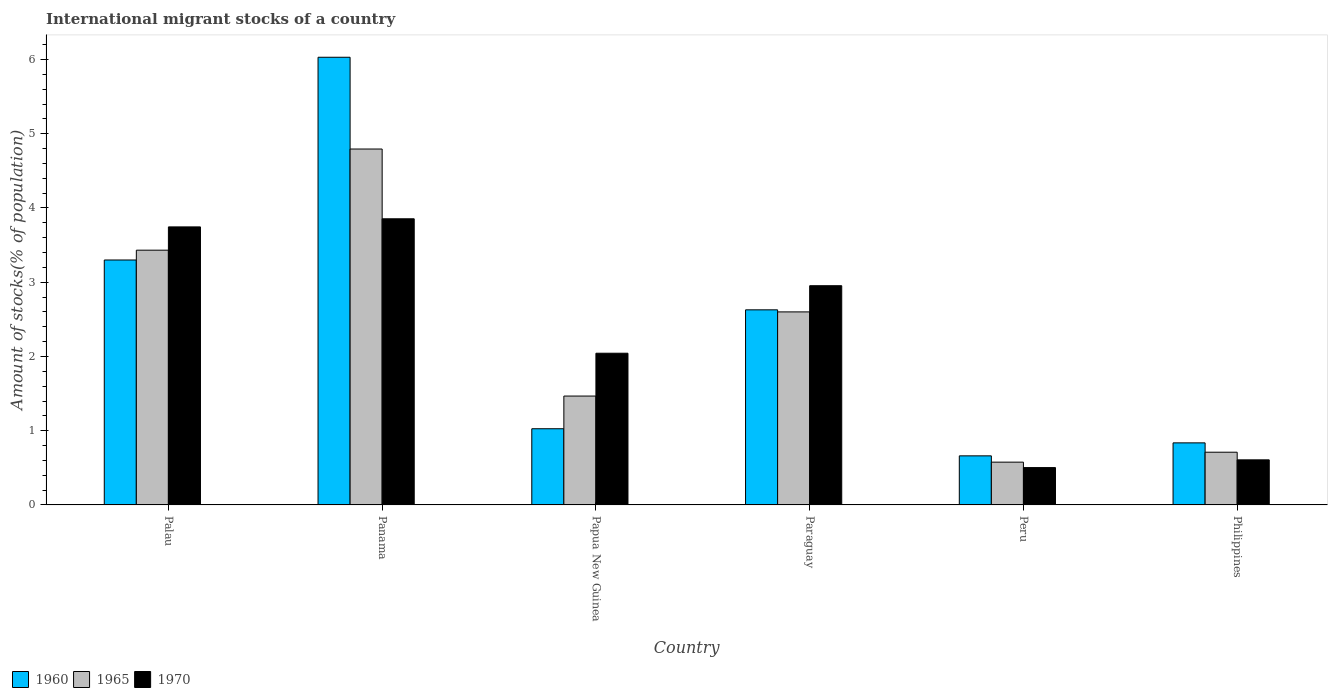Are the number of bars on each tick of the X-axis equal?
Give a very brief answer. Yes. How many bars are there on the 4th tick from the left?
Provide a short and direct response. 3. How many bars are there on the 1st tick from the right?
Your response must be concise. 3. What is the label of the 1st group of bars from the left?
Your answer should be compact. Palau. In how many cases, is the number of bars for a given country not equal to the number of legend labels?
Offer a very short reply. 0. What is the amount of stocks in in 1970 in Panama?
Provide a succinct answer. 3.85. Across all countries, what is the maximum amount of stocks in in 1960?
Keep it short and to the point. 6.03. Across all countries, what is the minimum amount of stocks in in 1960?
Provide a succinct answer. 0.66. In which country was the amount of stocks in in 1960 maximum?
Give a very brief answer. Panama. In which country was the amount of stocks in in 1970 minimum?
Keep it short and to the point. Peru. What is the total amount of stocks in in 1965 in the graph?
Your answer should be compact. 13.58. What is the difference between the amount of stocks in in 1965 in Palau and that in Philippines?
Your answer should be compact. 2.72. What is the difference between the amount of stocks in in 1960 in Philippines and the amount of stocks in in 1965 in Panama?
Offer a terse response. -3.96. What is the average amount of stocks in in 1965 per country?
Offer a very short reply. 2.26. What is the difference between the amount of stocks in of/in 1970 and amount of stocks in of/in 1965 in Peru?
Provide a succinct answer. -0.07. What is the ratio of the amount of stocks in in 1960 in Peru to that in Philippines?
Give a very brief answer. 0.79. Is the difference between the amount of stocks in in 1970 in Panama and Paraguay greater than the difference between the amount of stocks in in 1965 in Panama and Paraguay?
Your response must be concise. No. What is the difference between the highest and the second highest amount of stocks in in 1970?
Provide a succinct answer. 0.79. What is the difference between the highest and the lowest amount of stocks in in 1970?
Your answer should be compact. 3.35. In how many countries, is the amount of stocks in in 1960 greater than the average amount of stocks in in 1960 taken over all countries?
Make the answer very short. 3. Is the sum of the amount of stocks in in 1960 in Palau and Papua New Guinea greater than the maximum amount of stocks in in 1965 across all countries?
Your answer should be compact. No. What does the 3rd bar from the left in Paraguay represents?
Give a very brief answer. 1970. What does the 2nd bar from the right in Philippines represents?
Offer a terse response. 1965. Are all the bars in the graph horizontal?
Provide a short and direct response. No. How many countries are there in the graph?
Your answer should be very brief. 6. What is the difference between two consecutive major ticks on the Y-axis?
Ensure brevity in your answer.  1. What is the title of the graph?
Offer a very short reply. International migrant stocks of a country. What is the label or title of the X-axis?
Keep it short and to the point. Country. What is the label or title of the Y-axis?
Give a very brief answer. Amount of stocks(% of population). What is the Amount of stocks(% of population) of 1960 in Palau?
Provide a succinct answer. 3.3. What is the Amount of stocks(% of population) in 1965 in Palau?
Make the answer very short. 3.43. What is the Amount of stocks(% of population) of 1970 in Palau?
Give a very brief answer. 3.75. What is the Amount of stocks(% of population) of 1960 in Panama?
Your response must be concise. 6.03. What is the Amount of stocks(% of population) of 1965 in Panama?
Offer a terse response. 4.79. What is the Amount of stocks(% of population) of 1970 in Panama?
Make the answer very short. 3.85. What is the Amount of stocks(% of population) in 1960 in Papua New Guinea?
Ensure brevity in your answer.  1.03. What is the Amount of stocks(% of population) of 1965 in Papua New Guinea?
Ensure brevity in your answer.  1.47. What is the Amount of stocks(% of population) in 1970 in Papua New Guinea?
Your answer should be very brief. 2.04. What is the Amount of stocks(% of population) of 1960 in Paraguay?
Your answer should be very brief. 2.63. What is the Amount of stocks(% of population) in 1965 in Paraguay?
Your response must be concise. 2.6. What is the Amount of stocks(% of population) of 1970 in Paraguay?
Ensure brevity in your answer.  2.95. What is the Amount of stocks(% of population) of 1960 in Peru?
Offer a terse response. 0.66. What is the Amount of stocks(% of population) of 1965 in Peru?
Provide a short and direct response. 0.58. What is the Amount of stocks(% of population) of 1970 in Peru?
Your answer should be very brief. 0.5. What is the Amount of stocks(% of population) of 1960 in Philippines?
Your answer should be compact. 0.84. What is the Amount of stocks(% of population) of 1965 in Philippines?
Make the answer very short. 0.71. What is the Amount of stocks(% of population) in 1970 in Philippines?
Keep it short and to the point. 0.61. Across all countries, what is the maximum Amount of stocks(% of population) in 1960?
Offer a terse response. 6.03. Across all countries, what is the maximum Amount of stocks(% of population) in 1965?
Your answer should be very brief. 4.79. Across all countries, what is the maximum Amount of stocks(% of population) of 1970?
Make the answer very short. 3.85. Across all countries, what is the minimum Amount of stocks(% of population) of 1960?
Make the answer very short. 0.66. Across all countries, what is the minimum Amount of stocks(% of population) in 1965?
Give a very brief answer. 0.58. Across all countries, what is the minimum Amount of stocks(% of population) of 1970?
Give a very brief answer. 0.5. What is the total Amount of stocks(% of population) in 1960 in the graph?
Provide a short and direct response. 14.48. What is the total Amount of stocks(% of population) of 1965 in the graph?
Keep it short and to the point. 13.58. What is the total Amount of stocks(% of population) in 1970 in the graph?
Keep it short and to the point. 13.71. What is the difference between the Amount of stocks(% of population) of 1960 in Palau and that in Panama?
Ensure brevity in your answer.  -2.73. What is the difference between the Amount of stocks(% of population) of 1965 in Palau and that in Panama?
Your answer should be very brief. -1.36. What is the difference between the Amount of stocks(% of population) in 1970 in Palau and that in Panama?
Provide a succinct answer. -0.11. What is the difference between the Amount of stocks(% of population) in 1960 in Palau and that in Papua New Guinea?
Your answer should be very brief. 2.27. What is the difference between the Amount of stocks(% of population) in 1965 in Palau and that in Papua New Guinea?
Provide a succinct answer. 1.97. What is the difference between the Amount of stocks(% of population) in 1970 in Palau and that in Papua New Guinea?
Provide a short and direct response. 1.7. What is the difference between the Amount of stocks(% of population) of 1960 in Palau and that in Paraguay?
Offer a very short reply. 0.67. What is the difference between the Amount of stocks(% of population) in 1965 in Palau and that in Paraguay?
Keep it short and to the point. 0.83. What is the difference between the Amount of stocks(% of population) in 1970 in Palau and that in Paraguay?
Provide a short and direct response. 0.79. What is the difference between the Amount of stocks(% of population) in 1960 in Palau and that in Peru?
Offer a very short reply. 2.64. What is the difference between the Amount of stocks(% of population) of 1965 in Palau and that in Peru?
Your answer should be compact. 2.86. What is the difference between the Amount of stocks(% of population) of 1970 in Palau and that in Peru?
Your answer should be compact. 3.24. What is the difference between the Amount of stocks(% of population) of 1960 in Palau and that in Philippines?
Your answer should be very brief. 2.46. What is the difference between the Amount of stocks(% of population) of 1965 in Palau and that in Philippines?
Provide a short and direct response. 2.72. What is the difference between the Amount of stocks(% of population) of 1970 in Palau and that in Philippines?
Ensure brevity in your answer.  3.14. What is the difference between the Amount of stocks(% of population) of 1960 in Panama and that in Papua New Guinea?
Offer a terse response. 5. What is the difference between the Amount of stocks(% of population) in 1965 in Panama and that in Papua New Guinea?
Offer a terse response. 3.33. What is the difference between the Amount of stocks(% of population) in 1970 in Panama and that in Papua New Guinea?
Provide a succinct answer. 1.81. What is the difference between the Amount of stocks(% of population) of 1960 in Panama and that in Paraguay?
Provide a succinct answer. 3.4. What is the difference between the Amount of stocks(% of population) of 1965 in Panama and that in Paraguay?
Your answer should be very brief. 2.19. What is the difference between the Amount of stocks(% of population) in 1970 in Panama and that in Paraguay?
Offer a terse response. 0.9. What is the difference between the Amount of stocks(% of population) in 1960 in Panama and that in Peru?
Provide a succinct answer. 5.37. What is the difference between the Amount of stocks(% of population) of 1965 in Panama and that in Peru?
Keep it short and to the point. 4.22. What is the difference between the Amount of stocks(% of population) of 1970 in Panama and that in Peru?
Keep it short and to the point. 3.35. What is the difference between the Amount of stocks(% of population) of 1960 in Panama and that in Philippines?
Give a very brief answer. 5.19. What is the difference between the Amount of stocks(% of population) of 1965 in Panama and that in Philippines?
Offer a terse response. 4.08. What is the difference between the Amount of stocks(% of population) of 1970 in Panama and that in Philippines?
Offer a very short reply. 3.25. What is the difference between the Amount of stocks(% of population) in 1960 in Papua New Guinea and that in Paraguay?
Make the answer very short. -1.6. What is the difference between the Amount of stocks(% of population) in 1965 in Papua New Guinea and that in Paraguay?
Keep it short and to the point. -1.13. What is the difference between the Amount of stocks(% of population) in 1970 in Papua New Guinea and that in Paraguay?
Your answer should be compact. -0.91. What is the difference between the Amount of stocks(% of population) in 1960 in Papua New Guinea and that in Peru?
Provide a succinct answer. 0.37. What is the difference between the Amount of stocks(% of population) in 1965 in Papua New Guinea and that in Peru?
Your response must be concise. 0.89. What is the difference between the Amount of stocks(% of population) of 1970 in Papua New Guinea and that in Peru?
Offer a very short reply. 1.54. What is the difference between the Amount of stocks(% of population) in 1960 in Papua New Guinea and that in Philippines?
Make the answer very short. 0.19. What is the difference between the Amount of stocks(% of population) in 1965 in Papua New Guinea and that in Philippines?
Ensure brevity in your answer.  0.76. What is the difference between the Amount of stocks(% of population) in 1970 in Papua New Guinea and that in Philippines?
Provide a succinct answer. 1.44. What is the difference between the Amount of stocks(% of population) in 1960 in Paraguay and that in Peru?
Make the answer very short. 1.97. What is the difference between the Amount of stocks(% of population) in 1965 in Paraguay and that in Peru?
Offer a terse response. 2.02. What is the difference between the Amount of stocks(% of population) of 1970 in Paraguay and that in Peru?
Offer a very short reply. 2.45. What is the difference between the Amount of stocks(% of population) of 1960 in Paraguay and that in Philippines?
Provide a short and direct response. 1.79. What is the difference between the Amount of stocks(% of population) of 1965 in Paraguay and that in Philippines?
Your answer should be very brief. 1.89. What is the difference between the Amount of stocks(% of population) in 1970 in Paraguay and that in Philippines?
Keep it short and to the point. 2.35. What is the difference between the Amount of stocks(% of population) of 1960 in Peru and that in Philippines?
Offer a terse response. -0.17. What is the difference between the Amount of stocks(% of population) in 1965 in Peru and that in Philippines?
Offer a terse response. -0.13. What is the difference between the Amount of stocks(% of population) in 1970 in Peru and that in Philippines?
Your answer should be compact. -0.1. What is the difference between the Amount of stocks(% of population) in 1960 in Palau and the Amount of stocks(% of population) in 1965 in Panama?
Your response must be concise. -1.49. What is the difference between the Amount of stocks(% of population) of 1960 in Palau and the Amount of stocks(% of population) of 1970 in Panama?
Keep it short and to the point. -0.56. What is the difference between the Amount of stocks(% of population) of 1965 in Palau and the Amount of stocks(% of population) of 1970 in Panama?
Ensure brevity in your answer.  -0.42. What is the difference between the Amount of stocks(% of population) in 1960 in Palau and the Amount of stocks(% of population) in 1965 in Papua New Guinea?
Make the answer very short. 1.83. What is the difference between the Amount of stocks(% of population) in 1960 in Palau and the Amount of stocks(% of population) in 1970 in Papua New Guinea?
Give a very brief answer. 1.26. What is the difference between the Amount of stocks(% of population) in 1965 in Palau and the Amount of stocks(% of population) in 1970 in Papua New Guinea?
Ensure brevity in your answer.  1.39. What is the difference between the Amount of stocks(% of population) of 1960 in Palau and the Amount of stocks(% of population) of 1965 in Paraguay?
Provide a succinct answer. 0.7. What is the difference between the Amount of stocks(% of population) of 1960 in Palau and the Amount of stocks(% of population) of 1970 in Paraguay?
Give a very brief answer. 0.35. What is the difference between the Amount of stocks(% of population) in 1965 in Palau and the Amount of stocks(% of population) in 1970 in Paraguay?
Provide a succinct answer. 0.48. What is the difference between the Amount of stocks(% of population) in 1960 in Palau and the Amount of stocks(% of population) in 1965 in Peru?
Keep it short and to the point. 2.72. What is the difference between the Amount of stocks(% of population) of 1960 in Palau and the Amount of stocks(% of population) of 1970 in Peru?
Give a very brief answer. 2.8. What is the difference between the Amount of stocks(% of population) in 1965 in Palau and the Amount of stocks(% of population) in 1970 in Peru?
Offer a terse response. 2.93. What is the difference between the Amount of stocks(% of population) in 1960 in Palau and the Amount of stocks(% of population) in 1965 in Philippines?
Provide a succinct answer. 2.59. What is the difference between the Amount of stocks(% of population) of 1960 in Palau and the Amount of stocks(% of population) of 1970 in Philippines?
Offer a terse response. 2.69. What is the difference between the Amount of stocks(% of population) of 1965 in Palau and the Amount of stocks(% of population) of 1970 in Philippines?
Offer a very short reply. 2.82. What is the difference between the Amount of stocks(% of population) of 1960 in Panama and the Amount of stocks(% of population) of 1965 in Papua New Guinea?
Keep it short and to the point. 4.56. What is the difference between the Amount of stocks(% of population) in 1960 in Panama and the Amount of stocks(% of population) in 1970 in Papua New Guinea?
Offer a terse response. 3.99. What is the difference between the Amount of stocks(% of population) of 1965 in Panama and the Amount of stocks(% of population) of 1970 in Papua New Guinea?
Your response must be concise. 2.75. What is the difference between the Amount of stocks(% of population) in 1960 in Panama and the Amount of stocks(% of population) in 1965 in Paraguay?
Provide a short and direct response. 3.43. What is the difference between the Amount of stocks(% of population) of 1960 in Panama and the Amount of stocks(% of population) of 1970 in Paraguay?
Your answer should be compact. 3.08. What is the difference between the Amount of stocks(% of population) of 1965 in Panama and the Amount of stocks(% of population) of 1970 in Paraguay?
Ensure brevity in your answer.  1.84. What is the difference between the Amount of stocks(% of population) in 1960 in Panama and the Amount of stocks(% of population) in 1965 in Peru?
Give a very brief answer. 5.45. What is the difference between the Amount of stocks(% of population) in 1960 in Panama and the Amount of stocks(% of population) in 1970 in Peru?
Provide a short and direct response. 5.53. What is the difference between the Amount of stocks(% of population) in 1965 in Panama and the Amount of stocks(% of population) in 1970 in Peru?
Your answer should be compact. 4.29. What is the difference between the Amount of stocks(% of population) of 1960 in Panama and the Amount of stocks(% of population) of 1965 in Philippines?
Offer a terse response. 5.32. What is the difference between the Amount of stocks(% of population) in 1960 in Panama and the Amount of stocks(% of population) in 1970 in Philippines?
Provide a succinct answer. 5.42. What is the difference between the Amount of stocks(% of population) in 1965 in Panama and the Amount of stocks(% of population) in 1970 in Philippines?
Give a very brief answer. 4.19. What is the difference between the Amount of stocks(% of population) of 1960 in Papua New Guinea and the Amount of stocks(% of population) of 1965 in Paraguay?
Your answer should be compact. -1.57. What is the difference between the Amount of stocks(% of population) of 1960 in Papua New Guinea and the Amount of stocks(% of population) of 1970 in Paraguay?
Your response must be concise. -1.93. What is the difference between the Amount of stocks(% of population) of 1965 in Papua New Guinea and the Amount of stocks(% of population) of 1970 in Paraguay?
Your response must be concise. -1.49. What is the difference between the Amount of stocks(% of population) in 1960 in Papua New Guinea and the Amount of stocks(% of population) in 1965 in Peru?
Keep it short and to the point. 0.45. What is the difference between the Amount of stocks(% of population) of 1960 in Papua New Guinea and the Amount of stocks(% of population) of 1970 in Peru?
Your response must be concise. 0.52. What is the difference between the Amount of stocks(% of population) in 1965 in Papua New Guinea and the Amount of stocks(% of population) in 1970 in Peru?
Give a very brief answer. 0.96. What is the difference between the Amount of stocks(% of population) in 1960 in Papua New Guinea and the Amount of stocks(% of population) in 1965 in Philippines?
Offer a terse response. 0.32. What is the difference between the Amount of stocks(% of population) in 1960 in Papua New Guinea and the Amount of stocks(% of population) in 1970 in Philippines?
Give a very brief answer. 0.42. What is the difference between the Amount of stocks(% of population) in 1965 in Papua New Guinea and the Amount of stocks(% of population) in 1970 in Philippines?
Make the answer very short. 0.86. What is the difference between the Amount of stocks(% of population) in 1960 in Paraguay and the Amount of stocks(% of population) in 1965 in Peru?
Ensure brevity in your answer.  2.05. What is the difference between the Amount of stocks(% of population) in 1960 in Paraguay and the Amount of stocks(% of population) in 1970 in Peru?
Provide a succinct answer. 2.13. What is the difference between the Amount of stocks(% of population) of 1965 in Paraguay and the Amount of stocks(% of population) of 1970 in Peru?
Your answer should be compact. 2.1. What is the difference between the Amount of stocks(% of population) of 1960 in Paraguay and the Amount of stocks(% of population) of 1965 in Philippines?
Offer a very short reply. 1.92. What is the difference between the Amount of stocks(% of population) in 1960 in Paraguay and the Amount of stocks(% of population) in 1970 in Philippines?
Provide a short and direct response. 2.02. What is the difference between the Amount of stocks(% of population) of 1965 in Paraguay and the Amount of stocks(% of population) of 1970 in Philippines?
Give a very brief answer. 1.99. What is the difference between the Amount of stocks(% of population) of 1960 in Peru and the Amount of stocks(% of population) of 1965 in Philippines?
Your response must be concise. -0.05. What is the difference between the Amount of stocks(% of population) of 1960 in Peru and the Amount of stocks(% of population) of 1970 in Philippines?
Make the answer very short. 0.05. What is the difference between the Amount of stocks(% of population) of 1965 in Peru and the Amount of stocks(% of population) of 1970 in Philippines?
Offer a terse response. -0.03. What is the average Amount of stocks(% of population) in 1960 per country?
Provide a short and direct response. 2.41. What is the average Amount of stocks(% of population) in 1965 per country?
Offer a very short reply. 2.26. What is the average Amount of stocks(% of population) in 1970 per country?
Give a very brief answer. 2.28. What is the difference between the Amount of stocks(% of population) of 1960 and Amount of stocks(% of population) of 1965 in Palau?
Provide a short and direct response. -0.13. What is the difference between the Amount of stocks(% of population) of 1960 and Amount of stocks(% of population) of 1970 in Palau?
Ensure brevity in your answer.  -0.45. What is the difference between the Amount of stocks(% of population) of 1965 and Amount of stocks(% of population) of 1970 in Palau?
Make the answer very short. -0.31. What is the difference between the Amount of stocks(% of population) in 1960 and Amount of stocks(% of population) in 1965 in Panama?
Your answer should be very brief. 1.24. What is the difference between the Amount of stocks(% of population) in 1960 and Amount of stocks(% of population) in 1970 in Panama?
Your response must be concise. 2.18. What is the difference between the Amount of stocks(% of population) in 1965 and Amount of stocks(% of population) in 1970 in Panama?
Make the answer very short. 0.94. What is the difference between the Amount of stocks(% of population) of 1960 and Amount of stocks(% of population) of 1965 in Papua New Guinea?
Your answer should be very brief. -0.44. What is the difference between the Amount of stocks(% of population) of 1960 and Amount of stocks(% of population) of 1970 in Papua New Guinea?
Your answer should be very brief. -1.02. What is the difference between the Amount of stocks(% of population) of 1965 and Amount of stocks(% of population) of 1970 in Papua New Guinea?
Your response must be concise. -0.58. What is the difference between the Amount of stocks(% of population) of 1960 and Amount of stocks(% of population) of 1965 in Paraguay?
Your response must be concise. 0.03. What is the difference between the Amount of stocks(% of population) in 1960 and Amount of stocks(% of population) in 1970 in Paraguay?
Offer a terse response. -0.32. What is the difference between the Amount of stocks(% of population) of 1965 and Amount of stocks(% of population) of 1970 in Paraguay?
Offer a very short reply. -0.35. What is the difference between the Amount of stocks(% of population) of 1960 and Amount of stocks(% of population) of 1965 in Peru?
Ensure brevity in your answer.  0.08. What is the difference between the Amount of stocks(% of population) of 1960 and Amount of stocks(% of population) of 1970 in Peru?
Provide a succinct answer. 0.16. What is the difference between the Amount of stocks(% of population) in 1965 and Amount of stocks(% of population) in 1970 in Peru?
Give a very brief answer. 0.07. What is the difference between the Amount of stocks(% of population) in 1960 and Amount of stocks(% of population) in 1965 in Philippines?
Your response must be concise. 0.13. What is the difference between the Amount of stocks(% of population) of 1960 and Amount of stocks(% of population) of 1970 in Philippines?
Offer a terse response. 0.23. What is the difference between the Amount of stocks(% of population) of 1965 and Amount of stocks(% of population) of 1970 in Philippines?
Give a very brief answer. 0.1. What is the ratio of the Amount of stocks(% of population) of 1960 in Palau to that in Panama?
Ensure brevity in your answer.  0.55. What is the ratio of the Amount of stocks(% of population) in 1965 in Palau to that in Panama?
Give a very brief answer. 0.72. What is the ratio of the Amount of stocks(% of population) in 1970 in Palau to that in Panama?
Your response must be concise. 0.97. What is the ratio of the Amount of stocks(% of population) of 1960 in Palau to that in Papua New Guinea?
Keep it short and to the point. 3.21. What is the ratio of the Amount of stocks(% of population) of 1965 in Palau to that in Papua New Guinea?
Give a very brief answer. 2.34. What is the ratio of the Amount of stocks(% of population) in 1970 in Palau to that in Papua New Guinea?
Offer a terse response. 1.83. What is the ratio of the Amount of stocks(% of population) in 1960 in Palau to that in Paraguay?
Keep it short and to the point. 1.26. What is the ratio of the Amount of stocks(% of population) of 1965 in Palau to that in Paraguay?
Your answer should be compact. 1.32. What is the ratio of the Amount of stocks(% of population) of 1970 in Palau to that in Paraguay?
Your answer should be compact. 1.27. What is the ratio of the Amount of stocks(% of population) of 1960 in Palau to that in Peru?
Your response must be concise. 4.99. What is the ratio of the Amount of stocks(% of population) of 1965 in Palau to that in Peru?
Offer a very short reply. 5.95. What is the ratio of the Amount of stocks(% of population) of 1970 in Palau to that in Peru?
Give a very brief answer. 7.45. What is the ratio of the Amount of stocks(% of population) of 1960 in Palau to that in Philippines?
Ensure brevity in your answer.  3.95. What is the ratio of the Amount of stocks(% of population) in 1965 in Palau to that in Philippines?
Give a very brief answer. 4.83. What is the ratio of the Amount of stocks(% of population) of 1970 in Palau to that in Philippines?
Provide a short and direct response. 6.17. What is the ratio of the Amount of stocks(% of population) of 1960 in Panama to that in Papua New Guinea?
Give a very brief answer. 5.88. What is the ratio of the Amount of stocks(% of population) of 1965 in Panama to that in Papua New Guinea?
Provide a short and direct response. 3.27. What is the ratio of the Amount of stocks(% of population) in 1970 in Panama to that in Papua New Guinea?
Offer a very short reply. 1.89. What is the ratio of the Amount of stocks(% of population) of 1960 in Panama to that in Paraguay?
Ensure brevity in your answer.  2.29. What is the ratio of the Amount of stocks(% of population) in 1965 in Panama to that in Paraguay?
Your answer should be compact. 1.84. What is the ratio of the Amount of stocks(% of population) in 1970 in Panama to that in Paraguay?
Give a very brief answer. 1.31. What is the ratio of the Amount of stocks(% of population) of 1960 in Panama to that in Peru?
Your answer should be compact. 9.12. What is the ratio of the Amount of stocks(% of population) in 1965 in Panama to that in Peru?
Provide a short and direct response. 8.32. What is the ratio of the Amount of stocks(% of population) in 1970 in Panama to that in Peru?
Your answer should be compact. 7.66. What is the ratio of the Amount of stocks(% of population) in 1960 in Panama to that in Philippines?
Your answer should be very brief. 7.21. What is the ratio of the Amount of stocks(% of population) in 1965 in Panama to that in Philippines?
Provide a succinct answer. 6.75. What is the ratio of the Amount of stocks(% of population) of 1970 in Panama to that in Philippines?
Provide a short and direct response. 6.35. What is the ratio of the Amount of stocks(% of population) in 1960 in Papua New Guinea to that in Paraguay?
Keep it short and to the point. 0.39. What is the ratio of the Amount of stocks(% of population) in 1965 in Papua New Guinea to that in Paraguay?
Offer a very short reply. 0.56. What is the ratio of the Amount of stocks(% of population) in 1970 in Papua New Guinea to that in Paraguay?
Ensure brevity in your answer.  0.69. What is the ratio of the Amount of stocks(% of population) of 1960 in Papua New Guinea to that in Peru?
Give a very brief answer. 1.55. What is the ratio of the Amount of stocks(% of population) of 1965 in Papua New Guinea to that in Peru?
Offer a terse response. 2.54. What is the ratio of the Amount of stocks(% of population) in 1970 in Papua New Guinea to that in Peru?
Give a very brief answer. 4.06. What is the ratio of the Amount of stocks(% of population) of 1960 in Papua New Guinea to that in Philippines?
Provide a short and direct response. 1.23. What is the ratio of the Amount of stocks(% of population) of 1965 in Papua New Guinea to that in Philippines?
Offer a terse response. 2.06. What is the ratio of the Amount of stocks(% of population) of 1970 in Papua New Guinea to that in Philippines?
Provide a succinct answer. 3.37. What is the ratio of the Amount of stocks(% of population) in 1960 in Paraguay to that in Peru?
Ensure brevity in your answer.  3.98. What is the ratio of the Amount of stocks(% of population) of 1965 in Paraguay to that in Peru?
Offer a very short reply. 4.51. What is the ratio of the Amount of stocks(% of population) in 1970 in Paraguay to that in Peru?
Your answer should be compact. 5.87. What is the ratio of the Amount of stocks(% of population) in 1960 in Paraguay to that in Philippines?
Keep it short and to the point. 3.14. What is the ratio of the Amount of stocks(% of population) of 1965 in Paraguay to that in Philippines?
Provide a succinct answer. 3.66. What is the ratio of the Amount of stocks(% of population) of 1970 in Paraguay to that in Philippines?
Offer a very short reply. 4.86. What is the ratio of the Amount of stocks(% of population) in 1960 in Peru to that in Philippines?
Keep it short and to the point. 0.79. What is the ratio of the Amount of stocks(% of population) of 1965 in Peru to that in Philippines?
Offer a terse response. 0.81. What is the ratio of the Amount of stocks(% of population) in 1970 in Peru to that in Philippines?
Your answer should be compact. 0.83. What is the difference between the highest and the second highest Amount of stocks(% of population) of 1960?
Give a very brief answer. 2.73. What is the difference between the highest and the second highest Amount of stocks(% of population) of 1965?
Your answer should be very brief. 1.36. What is the difference between the highest and the second highest Amount of stocks(% of population) in 1970?
Ensure brevity in your answer.  0.11. What is the difference between the highest and the lowest Amount of stocks(% of population) of 1960?
Offer a terse response. 5.37. What is the difference between the highest and the lowest Amount of stocks(% of population) of 1965?
Provide a short and direct response. 4.22. What is the difference between the highest and the lowest Amount of stocks(% of population) in 1970?
Make the answer very short. 3.35. 